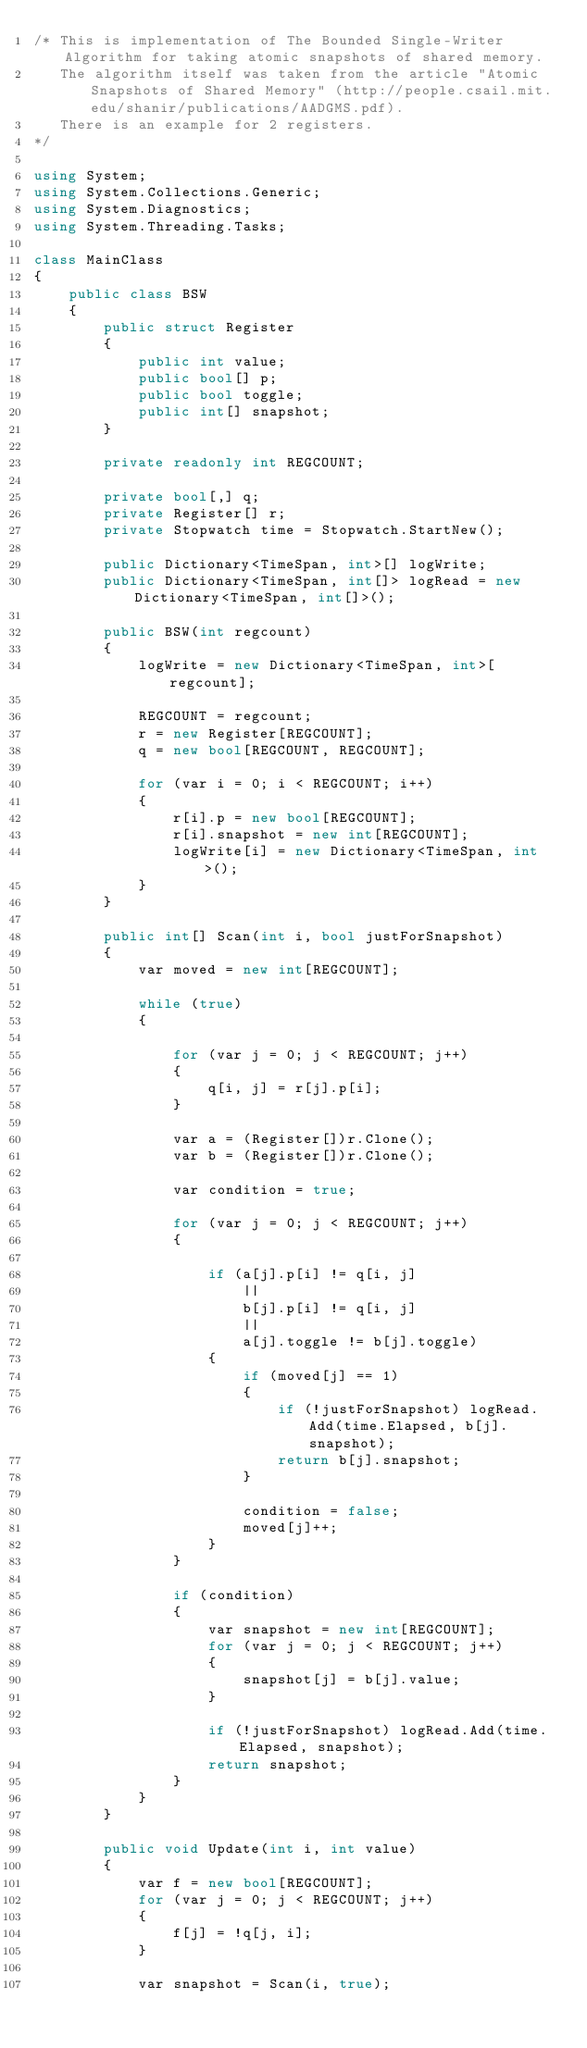<code> <loc_0><loc_0><loc_500><loc_500><_C#_>/* This is implementation of The Bounded Single-Writer Algorithm for taking atomic snapshots of shared memory.
   The algorithm itself was taken from the article "Atomic Snapshots of Shared Memory" (http://people.csail.mit.edu/shanir/publications/AADGMS.pdf).
   There is an example for 2 registers.
*/

using System;
using System.Collections.Generic;
using System.Diagnostics;
using System.Threading.Tasks;

class MainClass
{
    public class BSW
    {
        public struct Register
        {
            public int value;
            public bool[] p;
            public bool toggle;
            public int[] snapshot;
        }

        private readonly int REGCOUNT;

        private bool[,] q;
        private Register[] r;
        private Stopwatch time = Stopwatch.StartNew();

        public Dictionary<TimeSpan, int>[] logWrite;
        public Dictionary<TimeSpan, int[]> logRead = new Dictionary<TimeSpan, int[]>();

        public BSW(int regcount)
        {
            logWrite = new Dictionary<TimeSpan, int>[regcount];

            REGCOUNT = regcount;
            r = new Register[REGCOUNT];
            q = new bool[REGCOUNT, REGCOUNT];
            
            for (var i = 0; i < REGCOUNT; i++)
            {
                r[i].p = new bool[REGCOUNT];
                r[i].snapshot = new int[REGCOUNT];
                logWrite[i] = new Dictionary<TimeSpan, int>();
            }
        }

        public int[] Scan(int i, bool justForSnapshot)
        {
            var moved = new int[REGCOUNT];

            while (true)
            {
            
                for (var j = 0; j < REGCOUNT; j++)
                {
                    q[i, j] = r[j].p[i];
                }
    
                var a = (Register[])r.Clone();
                var b = (Register[])r.Clone();

                var condition = true;

                for (var j = 0; j < REGCOUNT; j++)
                {
                   
                    if (a[j].p[i] != q[i, j]
                        ||
                        b[j].p[i] != q[i, j]
                        ||
                        a[j].toggle != b[j].toggle)
                    {
                        if (moved[j] == 1)
                        {
                            if (!justForSnapshot) logRead.Add(time.Elapsed, b[j].snapshot);
                            return b[j].snapshot;
                        }

                        condition = false;
                        moved[j]++;
                    }
                }

                if (condition)
                {
                    var snapshot = new int[REGCOUNT];
                    for (var j = 0; j < REGCOUNT; j++)
                    {
                        snapshot[j] = b[j].value;
                    }

                    if (!justForSnapshot) logRead.Add(time.Elapsed, snapshot);
                    return snapshot;
                }
            }
        }

        public void Update(int i, int value)
        {
            var f = new bool[REGCOUNT];
            for (var j = 0; j < REGCOUNT; j++)
            {
                f[j] = !q[j, i];
            }

            var snapshot = Scan(i, true);
            </code> 